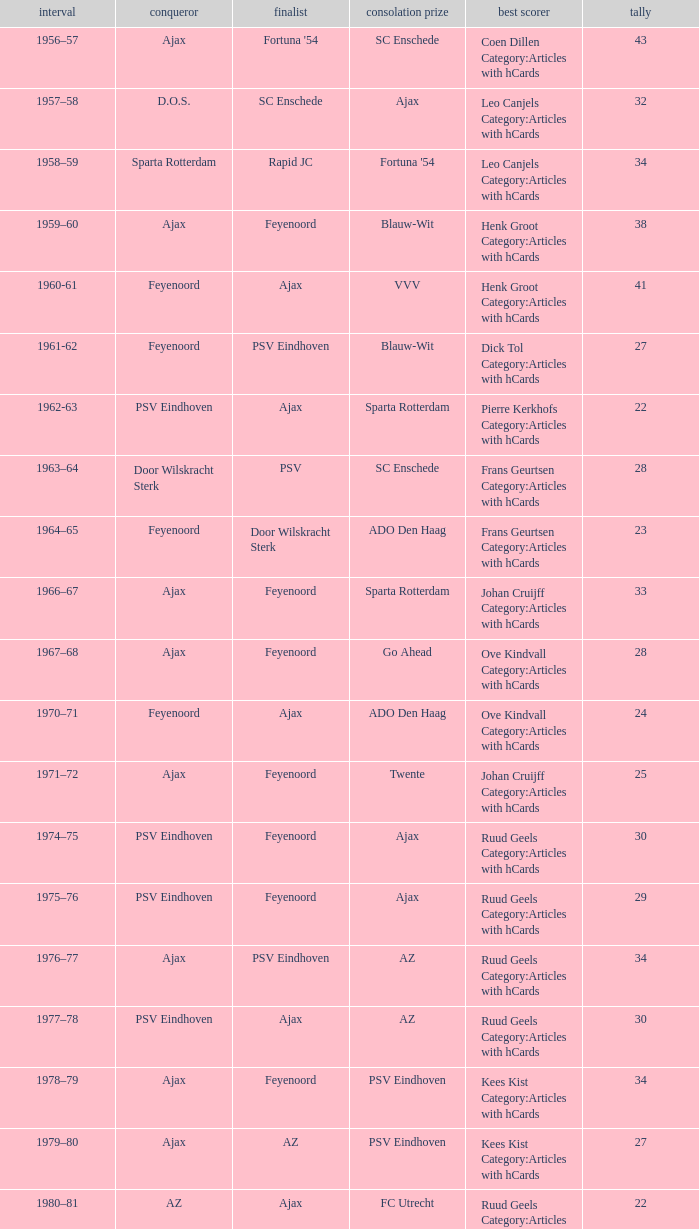When az is the runner up nad feyenoord came in third place how many overall winners are there? 1.0. 